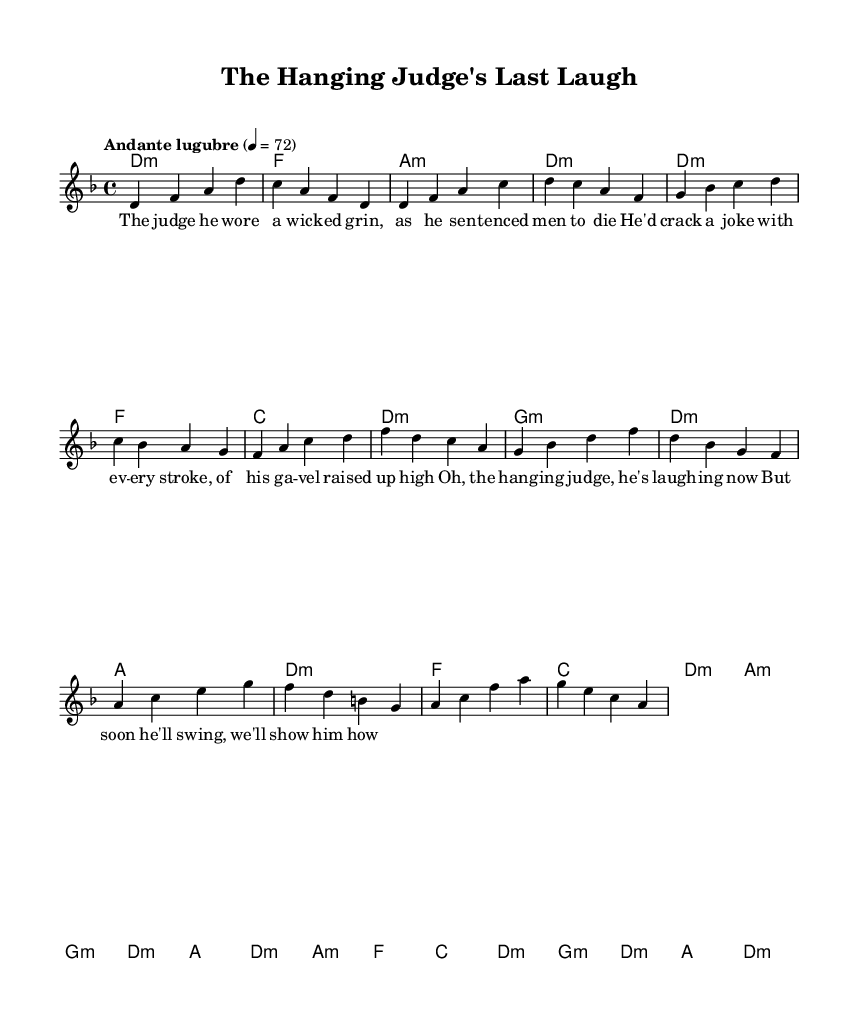What is the key signature of this music? The key signature is indicated at the beginning of the score. The presence of one flat indicates the key of D minor.
Answer: D minor What is the time signature of this music? The time signature is shown at the beginning right after the key signature. It is 4/4, meaning there are four beats in every measure, and the quarter note receives one beat.
Answer: 4/4 What is the tempo marking of this piece? The tempo marking is found above the staff under the title. It states "Andante lugubre," which suggests a slow and mournful pace.
Answer: Andante lugubre How many measures are in the verse section? The verse section is segmented into measures. Counting each segment in the 'verse' part reveals that there are eight measures in total.
Answer: Eight measures What type of humor is presented in the lyrics? The lyrics display a form of dark humor through the juxtaposition of a serious subject matter (a judge sentencing men to die) with levity (the judge cracks jokes). This humor tends to be macabre, aligning with the theme.
Answer: Dark humor What is the primary theme of the chorus? The chorus reflects the fate of the judge, who is currently laughing but will soon face a reckoning. This theme emphasizes irony and entrapment in the narrative.
Answer: Irony 